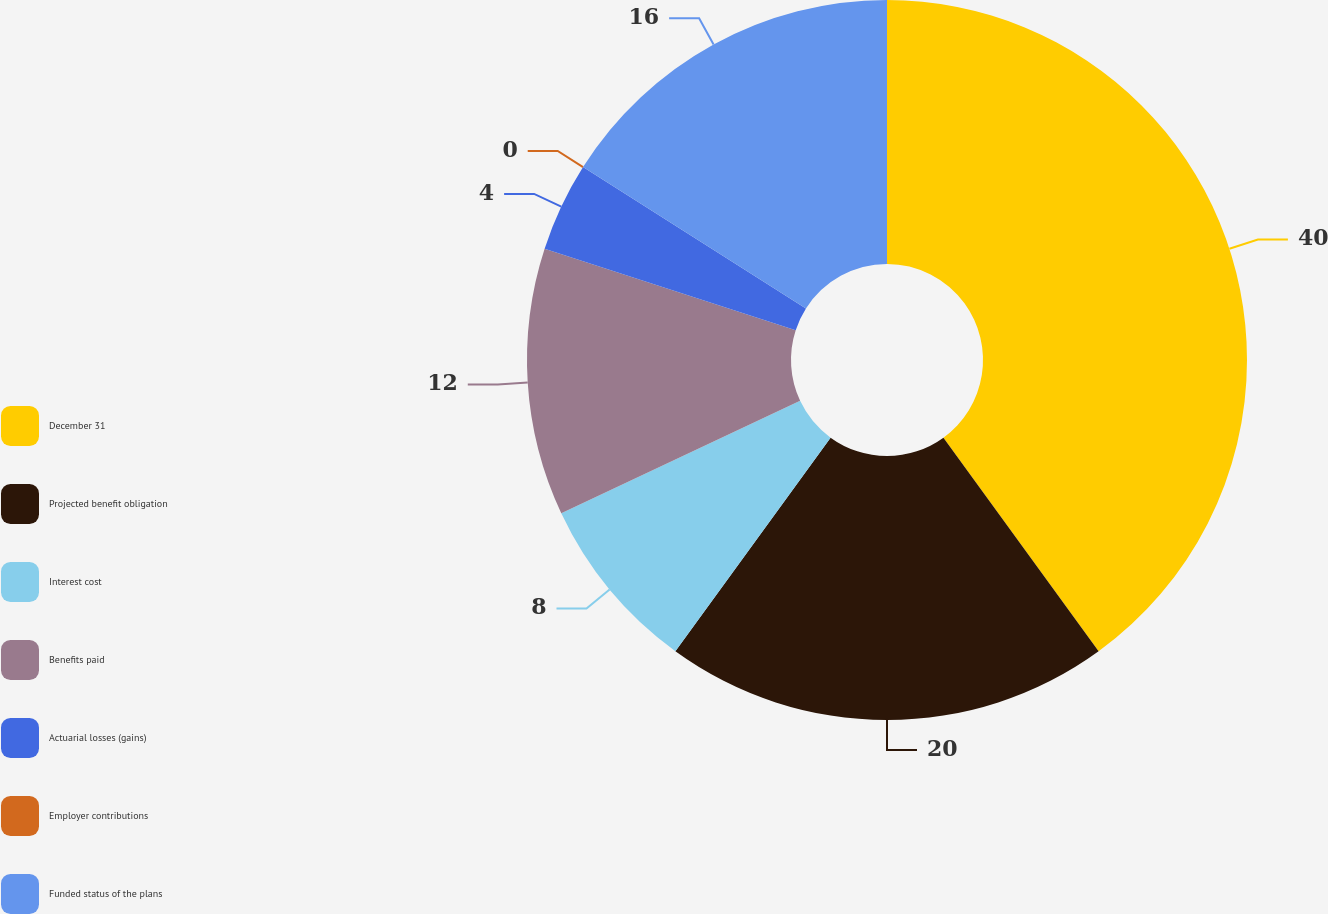Convert chart. <chart><loc_0><loc_0><loc_500><loc_500><pie_chart><fcel>December 31<fcel>Projected benefit obligation<fcel>Interest cost<fcel>Benefits paid<fcel>Actuarial losses (gains)<fcel>Employer contributions<fcel>Funded status of the plans<nl><fcel>40.0%<fcel>20.0%<fcel>8.0%<fcel>12.0%<fcel>4.0%<fcel>0.0%<fcel>16.0%<nl></chart> 